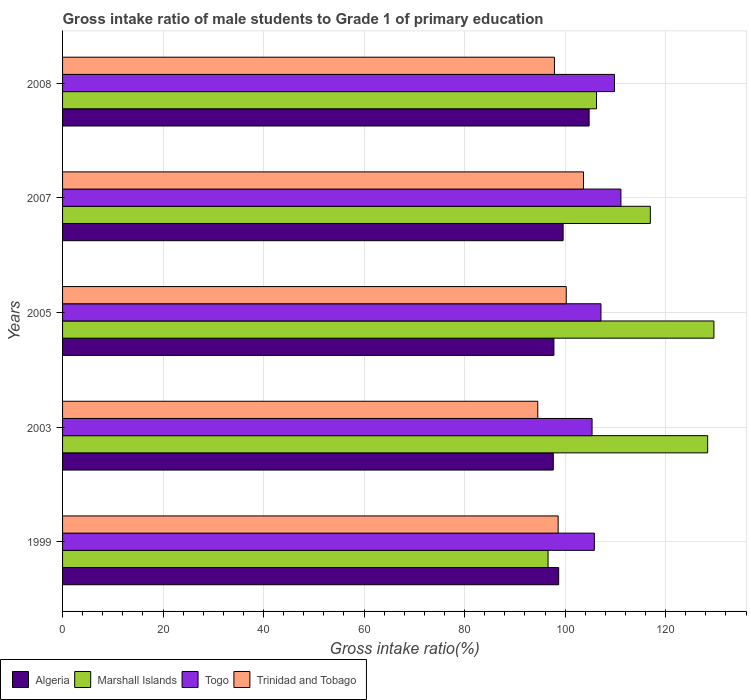How many bars are there on the 5th tick from the bottom?
Provide a short and direct response. 4. What is the label of the 1st group of bars from the top?
Your response must be concise. 2008. In how many cases, is the number of bars for a given year not equal to the number of legend labels?
Your answer should be compact. 0. What is the gross intake ratio in Trinidad and Tobago in 1999?
Ensure brevity in your answer.  98.62. Across all years, what is the maximum gross intake ratio in Togo?
Your response must be concise. 111.11. Across all years, what is the minimum gross intake ratio in Trinidad and Tobago?
Make the answer very short. 94.56. In which year was the gross intake ratio in Marshall Islands minimum?
Give a very brief answer. 1999. What is the total gross intake ratio in Togo in the graph?
Offer a terse response. 539.26. What is the difference between the gross intake ratio in Togo in 1999 and that in 2007?
Provide a short and direct response. -5.28. What is the difference between the gross intake ratio in Algeria in 2005 and the gross intake ratio in Marshall Islands in 1999?
Keep it short and to the point. 1.17. What is the average gross intake ratio in Trinidad and Tobago per year?
Ensure brevity in your answer.  98.99. In the year 2003, what is the difference between the gross intake ratio in Algeria and gross intake ratio in Trinidad and Tobago?
Provide a short and direct response. 3.08. In how many years, is the gross intake ratio in Togo greater than 32 %?
Ensure brevity in your answer.  5. What is the ratio of the gross intake ratio in Marshall Islands in 2003 to that in 2007?
Keep it short and to the point. 1.1. What is the difference between the highest and the second highest gross intake ratio in Algeria?
Provide a short and direct response. 5.18. What is the difference between the highest and the lowest gross intake ratio in Togo?
Provide a short and direct response. 5.74. In how many years, is the gross intake ratio in Marshall Islands greater than the average gross intake ratio in Marshall Islands taken over all years?
Your answer should be compact. 3. Is the sum of the gross intake ratio in Algeria in 2003 and 2007 greater than the maximum gross intake ratio in Togo across all years?
Your answer should be very brief. Yes. Is it the case that in every year, the sum of the gross intake ratio in Trinidad and Tobago and gross intake ratio in Algeria is greater than the sum of gross intake ratio in Marshall Islands and gross intake ratio in Togo?
Keep it short and to the point. No. What does the 2nd bar from the top in 2007 represents?
Your answer should be compact. Togo. What does the 1st bar from the bottom in 2008 represents?
Ensure brevity in your answer.  Algeria. Is it the case that in every year, the sum of the gross intake ratio in Algeria and gross intake ratio in Marshall Islands is greater than the gross intake ratio in Togo?
Offer a very short reply. Yes. Are all the bars in the graph horizontal?
Ensure brevity in your answer.  Yes. What is the difference between two consecutive major ticks on the X-axis?
Offer a very short reply. 20. Does the graph contain grids?
Provide a short and direct response. Yes. How many legend labels are there?
Offer a very short reply. 4. What is the title of the graph?
Offer a terse response. Gross intake ratio of male students to Grade 1 of primary education. Does "Arab World" appear as one of the legend labels in the graph?
Provide a short and direct response. No. What is the label or title of the X-axis?
Give a very brief answer. Gross intake ratio(%). What is the Gross intake ratio(%) in Algeria in 1999?
Provide a succinct answer. 98.72. What is the Gross intake ratio(%) in Marshall Islands in 1999?
Offer a terse response. 96.61. What is the Gross intake ratio(%) of Togo in 1999?
Offer a terse response. 105.82. What is the Gross intake ratio(%) in Trinidad and Tobago in 1999?
Your response must be concise. 98.62. What is the Gross intake ratio(%) of Algeria in 2003?
Your response must be concise. 97.65. What is the Gross intake ratio(%) of Marshall Islands in 2003?
Your answer should be compact. 128.37. What is the Gross intake ratio(%) in Togo in 2003?
Your response must be concise. 105.37. What is the Gross intake ratio(%) in Trinidad and Tobago in 2003?
Provide a succinct answer. 94.56. What is the Gross intake ratio(%) in Algeria in 2005?
Make the answer very short. 97.77. What is the Gross intake ratio(%) of Marshall Islands in 2005?
Your answer should be very brief. 129.61. What is the Gross intake ratio(%) in Togo in 2005?
Your answer should be compact. 107.14. What is the Gross intake ratio(%) of Trinidad and Tobago in 2005?
Give a very brief answer. 100.23. What is the Gross intake ratio(%) in Algeria in 2007?
Ensure brevity in your answer.  99.61. What is the Gross intake ratio(%) in Marshall Islands in 2007?
Make the answer very short. 116.96. What is the Gross intake ratio(%) in Togo in 2007?
Provide a succinct answer. 111.11. What is the Gross intake ratio(%) of Trinidad and Tobago in 2007?
Your answer should be compact. 103.66. What is the Gross intake ratio(%) in Algeria in 2008?
Provide a succinct answer. 104.78. What is the Gross intake ratio(%) in Marshall Islands in 2008?
Offer a very short reply. 106.25. What is the Gross intake ratio(%) of Togo in 2008?
Make the answer very short. 109.83. What is the Gross intake ratio(%) of Trinidad and Tobago in 2008?
Keep it short and to the point. 97.88. Across all years, what is the maximum Gross intake ratio(%) in Algeria?
Keep it short and to the point. 104.78. Across all years, what is the maximum Gross intake ratio(%) of Marshall Islands?
Provide a short and direct response. 129.61. Across all years, what is the maximum Gross intake ratio(%) of Togo?
Offer a very short reply. 111.11. Across all years, what is the maximum Gross intake ratio(%) in Trinidad and Tobago?
Your answer should be very brief. 103.66. Across all years, what is the minimum Gross intake ratio(%) of Algeria?
Give a very brief answer. 97.65. Across all years, what is the minimum Gross intake ratio(%) of Marshall Islands?
Ensure brevity in your answer.  96.61. Across all years, what is the minimum Gross intake ratio(%) in Togo?
Your response must be concise. 105.37. Across all years, what is the minimum Gross intake ratio(%) in Trinidad and Tobago?
Ensure brevity in your answer.  94.56. What is the total Gross intake ratio(%) of Algeria in the graph?
Your answer should be compact. 498.53. What is the total Gross intake ratio(%) in Marshall Islands in the graph?
Offer a very short reply. 577.8. What is the total Gross intake ratio(%) in Togo in the graph?
Keep it short and to the point. 539.26. What is the total Gross intake ratio(%) of Trinidad and Tobago in the graph?
Keep it short and to the point. 494.95. What is the difference between the Gross intake ratio(%) of Algeria in 1999 and that in 2003?
Provide a short and direct response. 1.08. What is the difference between the Gross intake ratio(%) in Marshall Islands in 1999 and that in 2003?
Keep it short and to the point. -31.76. What is the difference between the Gross intake ratio(%) of Togo in 1999 and that in 2003?
Provide a succinct answer. 0.46. What is the difference between the Gross intake ratio(%) of Trinidad and Tobago in 1999 and that in 2003?
Keep it short and to the point. 4.06. What is the difference between the Gross intake ratio(%) of Algeria in 1999 and that in 2005?
Provide a short and direct response. 0.95. What is the difference between the Gross intake ratio(%) in Marshall Islands in 1999 and that in 2005?
Your answer should be very brief. -33.01. What is the difference between the Gross intake ratio(%) of Togo in 1999 and that in 2005?
Give a very brief answer. -1.31. What is the difference between the Gross intake ratio(%) of Trinidad and Tobago in 1999 and that in 2005?
Offer a very short reply. -1.61. What is the difference between the Gross intake ratio(%) of Algeria in 1999 and that in 2007?
Provide a short and direct response. -0.88. What is the difference between the Gross intake ratio(%) in Marshall Islands in 1999 and that in 2007?
Ensure brevity in your answer.  -20.35. What is the difference between the Gross intake ratio(%) of Togo in 1999 and that in 2007?
Your response must be concise. -5.28. What is the difference between the Gross intake ratio(%) in Trinidad and Tobago in 1999 and that in 2007?
Your answer should be very brief. -5.04. What is the difference between the Gross intake ratio(%) of Algeria in 1999 and that in 2008?
Give a very brief answer. -6.06. What is the difference between the Gross intake ratio(%) of Marshall Islands in 1999 and that in 2008?
Your answer should be compact. -9.64. What is the difference between the Gross intake ratio(%) of Togo in 1999 and that in 2008?
Provide a succinct answer. -4.01. What is the difference between the Gross intake ratio(%) in Trinidad and Tobago in 1999 and that in 2008?
Your answer should be very brief. 0.74. What is the difference between the Gross intake ratio(%) of Algeria in 2003 and that in 2005?
Your answer should be compact. -0.13. What is the difference between the Gross intake ratio(%) in Marshall Islands in 2003 and that in 2005?
Offer a very short reply. -1.25. What is the difference between the Gross intake ratio(%) in Togo in 2003 and that in 2005?
Offer a terse response. -1.77. What is the difference between the Gross intake ratio(%) in Trinidad and Tobago in 2003 and that in 2005?
Offer a very short reply. -5.67. What is the difference between the Gross intake ratio(%) in Algeria in 2003 and that in 2007?
Ensure brevity in your answer.  -1.96. What is the difference between the Gross intake ratio(%) of Marshall Islands in 2003 and that in 2007?
Give a very brief answer. 11.4. What is the difference between the Gross intake ratio(%) of Togo in 2003 and that in 2007?
Offer a terse response. -5.74. What is the difference between the Gross intake ratio(%) in Trinidad and Tobago in 2003 and that in 2007?
Your response must be concise. -9.1. What is the difference between the Gross intake ratio(%) in Algeria in 2003 and that in 2008?
Your response must be concise. -7.14. What is the difference between the Gross intake ratio(%) of Marshall Islands in 2003 and that in 2008?
Your answer should be compact. 22.12. What is the difference between the Gross intake ratio(%) in Togo in 2003 and that in 2008?
Your response must be concise. -4.46. What is the difference between the Gross intake ratio(%) of Trinidad and Tobago in 2003 and that in 2008?
Keep it short and to the point. -3.32. What is the difference between the Gross intake ratio(%) in Algeria in 2005 and that in 2007?
Keep it short and to the point. -1.83. What is the difference between the Gross intake ratio(%) of Marshall Islands in 2005 and that in 2007?
Your answer should be very brief. 12.65. What is the difference between the Gross intake ratio(%) of Togo in 2005 and that in 2007?
Keep it short and to the point. -3.97. What is the difference between the Gross intake ratio(%) in Trinidad and Tobago in 2005 and that in 2007?
Offer a very short reply. -3.43. What is the difference between the Gross intake ratio(%) of Algeria in 2005 and that in 2008?
Offer a terse response. -7.01. What is the difference between the Gross intake ratio(%) in Marshall Islands in 2005 and that in 2008?
Ensure brevity in your answer.  23.36. What is the difference between the Gross intake ratio(%) in Togo in 2005 and that in 2008?
Your answer should be very brief. -2.69. What is the difference between the Gross intake ratio(%) of Trinidad and Tobago in 2005 and that in 2008?
Ensure brevity in your answer.  2.35. What is the difference between the Gross intake ratio(%) of Algeria in 2007 and that in 2008?
Give a very brief answer. -5.18. What is the difference between the Gross intake ratio(%) of Marshall Islands in 2007 and that in 2008?
Your answer should be compact. 10.71. What is the difference between the Gross intake ratio(%) of Togo in 2007 and that in 2008?
Give a very brief answer. 1.28. What is the difference between the Gross intake ratio(%) of Trinidad and Tobago in 2007 and that in 2008?
Make the answer very short. 5.78. What is the difference between the Gross intake ratio(%) of Algeria in 1999 and the Gross intake ratio(%) of Marshall Islands in 2003?
Offer a very short reply. -29.64. What is the difference between the Gross intake ratio(%) in Algeria in 1999 and the Gross intake ratio(%) in Togo in 2003?
Offer a terse response. -6.64. What is the difference between the Gross intake ratio(%) in Algeria in 1999 and the Gross intake ratio(%) in Trinidad and Tobago in 2003?
Your answer should be compact. 4.16. What is the difference between the Gross intake ratio(%) in Marshall Islands in 1999 and the Gross intake ratio(%) in Togo in 2003?
Your answer should be very brief. -8.76. What is the difference between the Gross intake ratio(%) of Marshall Islands in 1999 and the Gross intake ratio(%) of Trinidad and Tobago in 2003?
Give a very brief answer. 2.05. What is the difference between the Gross intake ratio(%) in Togo in 1999 and the Gross intake ratio(%) in Trinidad and Tobago in 2003?
Ensure brevity in your answer.  11.26. What is the difference between the Gross intake ratio(%) in Algeria in 1999 and the Gross intake ratio(%) in Marshall Islands in 2005?
Your response must be concise. -30.89. What is the difference between the Gross intake ratio(%) of Algeria in 1999 and the Gross intake ratio(%) of Togo in 2005?
Ensure brevity in your answer.  -8.41. What is the difference between the Gross intake ratio(%) in Algeria in 1999 and the Gross intake ratio(%) in Trinidad and Tobago in 2005?
Offer a very short reply. -1.5. What is the difference between the Gross intake ratio(%) in Marshall Islands in 1999 and the Gross intake ratio(%) in Togo in 2005?
Offer a very short reply. -10.53. What is the difference between the Gross intake ratio(%) in Marshall Islands in 1999 and the Gross intake ratio(%) in Trinidad and Tobago in 2005?
Keep it short and to the point. -3.62. What is the difference between the Gross intake ratio(%) of Togo in 1999 and the Gross intake ratio(%) of Trinidad and Tobago in 2005?
Keep it short and to the point. 5.6. What is the difference between the Gross intake ratio(%) in Algeria in 1999 and the Gross intake ratio(%) in Marshall Islands in 2007?
Offer a terse response. -18.24. What is the difference between the Gross intake ratio(%) in Algeria in 1999 and the Gross intake ratio(%) in Togo in 2007?
Ensure brevity in your answer.  -12.38. What is the difference between the Gross intake ratio(%) in Algeria in 1999 and the Gross intake ratio(%) in Trinidad and Tobago in 2007?
Ensure brevity in your answer.  -4.94. What is the difference between the Gross intake ratio(%) of Marshall Islands in 1999 and the Gross intake ratio(%) of Togo in 2007?
Offer a terse response. -14.5. What is the difference between the Gross intake ratio(%) of Marshall Islands in 1999 and the Gross intake ratio(%) of Trinidad and Tobago in 2007?
Give a very brief answer. -7.05. What is the difference between the Gross intake ratio(%) in Togo in 1999 and the Gross intake ratio(%) in Trinidad and Tobago in 2007?
Provide a short and direct response. 2.16. What is the difference between the Gross intake ratio(%) of Algeria in 1999 and the Gross intake ratio(%) of Marshall Islands in 2008?
Give a very brief answer. -7.53. What is the difference between the Gross intake ratio(%) of Algeria in 1999 and the Gross intake ratio(%) of Togo in 2008?
Your answer should be compact. -11.1. What is the difference between the Gross intake ratio(%) in Algeria in 1999 and the Gross intake ratio(%) in Trinidad and Tobago in 2008?
Your answer should be very brief. 0.85. What is the difference between the Gross intake ratio(%) of Marshall Islands in 1999 and the Gross intake ratio(%) of Togo in 2008?
Make the answer very short. -13.22. What is the difference between the Gross intake ratio(%) of Marshall Islands in 1999 and the Gross intake ratio(%) of Trinidad and Tobago in 2008?
Your answer should be compact. -1.27. What is the difference between the Gross intake ratio(%) in Togo in 1999 and the Gross intake ratio(%) in Trinidad and Tobago in 2008?
Ensure brevity in your answer.  7.94. What is the difference between the Gross intake ratio(%) of Algeria in 2003 and the Gross intake ratio(%) of Marshall Islands in 2005?
Your answer should be compact. -31.97. What is the difference between the Gross intake ratio(%) of Algeria in 2003 and the Gross intake ratio(%) of Togo in 2005?
Offer a very short reply. -9.49. What is the difference between the Gross intake ratio(%) in Algeria in 2003 and the Gross intake ratio(%) in Trinidad and Tobago in 2005?
Ensure brevity in your answer.  -2.58. What is the difference between the Gross intake ratio(%) in Marshall Islands in 2003 and the Gross intake ratio(%) in Togo in 2005?
Provide a short and direct response. 21.23. What is the difference between the Gross intake ratio(%) of Marshall Islands in 2003 and the Gross intake ratio(%) of Trinidad and Tobago in 2005?
Your answer should be compact. 28.14. What is the difference between the Gross intake ratio(%) in Togo in 2003 and the Gross intake ratio(%) in Trinidad and Tobago in 2005?
Your answer should be very brief. 5.14. What is the difference between the Gross intake ratio(%) in Algeria in 2003 and the Gross intake ratio(%) in Marshall Islands in 2007?
Your answer should be compact. -19.31. What is the difference between the Gross intake ratio(%) in Algeria in 2003 and the Gross intake ratio(%) in Togo in 2007?
Provide a short and direct response. -13.46. What is the difference between the Gross intake ratio(%) of Algeria in 2003 and the Gross intake ratio(%) of Trinidad and Tobago in 2007?
Give a very brief answer. -6.02. What is the difference between the Gross intake ratio(%) of Marshall Islands in 2003 and the Gross intake ratio(%) of Togo in 2007?
Offer a terse response. 17.26. What is the difference between the Gross intake ratio(%) in Marshall Islands in 2003 and the Gross intake ratio(%) in Trinidad and Tobago in 2007?
Make the answer very short. 24.7. What is the difference between the Gross intake ratio(%) in Togo in 2003 and the Gross intake ratio(%) in Trinidad and Tobago in 2007?
Your response must be concise. 1.71. What is the difference between the Gross intake ratio(%) of Algeria in 2003 and the Gross intake ratio(%) of Marshall Islands in 2008?
Your response must be concise. -8.6. What is the difference between the Gross intake ratio(%) in Algeria in 2003 and the Gross intake ratio(%) in Togo in 2008?
Your answer should be compact. -12.18. What is the difference between the Gross intake ratio(%) of Algeria in 2003 and the Gross intake ratio(%) of Trinidad and Tobago in 2008?
Offer a very short reply. -0.23. What is the difference between the Gross intake ratio(%) of Marshall Islands in 2003 and the Gross intake ratio(%) of Togo in 2008?
Provide a succinct answer. 18.54. What is the difference between the Gross intake ratio(%) in Marshall Islands in 2003 and the Gross intake ratio(%) in Trinidad and Tobago in 2008?
Your answer should be compact. 30.49. What is the difference between the Gross intake ratio(%) of Togo in 2003 and the Gross intake ratio(%) of Trinidad and Tobago in 2008?
Keep it short and to the point. 7.49. What is the difference between the Gross intake ratio(%) of Algeria in 2005 and the Gross intake ratio(%) of Marshall Islands in 2007?
Make the answer very short. -19.19. What is the difference between the Gross intake ratio(%) of Algeria in 2005 and the Gross intake ratio(%) of Togo in 2007?
Offer a very short reply. -13.33. What is the difference between the Gross intake ratio(%) of Algeria in 2005 and the Gross intake ratio(%) of Trinidad and Tobago in 2007?
Your response must be concise. -5.89. What is the difference between the Gross intake ratio(%) in Marshall Islands in 2005 and the Gross intake ratio(%) in Togo in 2007?
Your answer should be very brief. 18.51. What is the difference between the Gross intake ratio(%) in Marshall Islands in 2005 and the Gross intake ratio(%) in Trinidad and Tobago in 2007?
Keep it short and to the point. 25.95. What is the difference between the Gross intake ratio(%) in Togo in 2005 and the Gross intake ratio(%) in Trinidad and Tobago in 2007?
Your answer should be compact. 3.47. What is the difference between the Gross intake ratio(%) in Algeria in 2005 and the Gross intake ratio(%) in Marshall Islands in 2008?
Keep it short and to the point. -8.48. What is the difference between the Gross intake ratio(%) in Algeria in 2005 and the Gross intake ratio(%) in Togo in 2008?
Your response must be concise. -12.05. What is the difference between the Gross intake ratio(%) of Algeria in 2005 and the Gross intake ratio(%) of Trinidad and Tobago in 2008?
Ensure brevity in your answer.  -0.1. What is the difference between the Gross intake ratio(%) in Marshall Islands in 2005 and the Gross intake ratio(%) in Togo in 2008?
Give a very brief answer. 19.78. What is the difference between the Gross intake ratio(%) of Marshall Islands in 2005 and the Gross intake ratio(%) of Trinidad and Tobago in 2008?
Ensure brevity in your answer.  31.73. What is the difference between the Gross intake ratio(%) of Togo in 2005 and the Gross intake ratio(%) of Trinidad and Tobago in 2008?
Provide a succinct answer. 9.26. What is the difference between the Gross intake ratio(%) in Algeria in 2007 and the Gross intake ratio(%) in Marshall Islands in 2008?
Keep it short and to the point. -6.64. What is the difference between the Gross intake ratio(%) of Algeria in 2007 and the Gross intake ratio(%) of Togo in 2008?
Your response must be concise. -10.22. What is the difference between the Gross intake ratio(%) in Algeria in 2007 and the Gross intake ratio(%) in Trinidad and Tobago in 2008?
Ensure brevity in your answer.  1.73. What is the difference between the Gross intake ratio(%) of Marshall Islands in 2007 and the Gross intake ratio(%) of Togo in 2008?
Keep it short and to the point. 7.13. What is the difference between the Gross intake ratio(%) of Marshall Islands in 2007 and the Gross intake ratio(%) of Trinidad and Tobago in 2008?
Ensure brevity in your answer.  19.08. What is the difference between the Gross intake ratio(%) in Togo in 2007 and the Gross intake ratio(%) in Trinidad and Tobago in 2008?
Keep it short and to the point. 13.23. What is the average Gross intake ratio(%) of Algeria per year?
Your answer should be compact. 99.71. What is the average Gross intake ratio(%) of Marshall Islands per year?
Give a very brief answer. 115.56. What is the average Gross intake ratio(%) in Togo per year?
Keep it short and to the point. 107.85. What is the average Gross intake ratio(%) of Trinidad and Tobago per year?
Your answer should be very brief. 98.99. In the year 1999, what is the difference between the Gross intake ratio(%) in Algeria and Gross intake ratio(%) in Marshall Islands?
Your response must be concise. 2.12. In the year 1999, what is the difference between the Gross intake ratio(%) in Algeria and Gross intake ratio(%) in Togo?
Offer a very short reply. -7.1. In the year 1999, what is the difference between the Gross intake ratio(%) in Algeria and Gross intake ratio(%) in Trinidad and Tobago?
Keep it short and to the point. 0.11. In the year 1999, what is the difference between the Gross intake ratio(%) of Marshall Islands and Gross intake ratio(%) of Togo?
Your answer should be compact. -9.22. In the year 1999, what is the difference between the Gross intake ratio(%) of Marshall Islands and Gross intake ratio(%) of Trinidad and Tobago?
Keep it short and to the point. -2.01. In the year 1999, what is the difference between the Gross intake ratio(%) in Togo and Gross intake ratio(%) in Trinidad and Tobago?
Provide a succinct answer. 7.2. In the year 2003, what is the difference between the Gross intake ratio(%) of Algeria and Gross intake ratio(%) of Marshall Islands?
Keep it short and to the point. -30.72. In the year 2003, what is the difference between the Gross intake ratio(%) of Algeria and Gross intake ratio(%) of Togo?
Provide a succinct answer. -7.72. In the year 2003, what is the difference between the Gross intake ratio(%) of Algeria and Gross intake ratio(%) of Trinidad and Tobago?
Ensure brevity in your answer.  3.08. In the year 2003, what is the difference between the Gross intake ratio(%) in Marshall Islands and Gross intake ratio(%) in Togo?
Provide a short and direct response. 23. In the year 2003, what is the difference between the Gross intake ratio(%) in Marshall Islands and Gross intake ratio(%) in Trinidad and Tobago?
Provide a succinct answer. 33.8. In the year 2003, what is the difference between the Gross intake ratio(%) of Togo and Gross intake ratio(%) of Trinidad and Tobago?
Keep it short and to the point. 10.8. In the year 2005, what is the difference between the Gross intake ratio(%) of Algeria and Gross intake ratio(%) of Marshall Islands?
Your response must be concise. -31.84. In the year 2005, what is the difference between the Gross intake ratio(%) in Algeria and Gross intake ratio(%) in Togo?
Provide a short and direct response. -9.36. In the year 2005, what is the difference between the Gross intake ratio(%) of Algeria and Gross intake ratio(%) of Trinidad and Tobago?
Offer a terse response. -2.45. In the year 2005, what is the difference between the Gross intake ratio(%) of Marshall Islands and Gross intake ratio(%) of Togo?
Offer a very short reply. 22.48. In the year 2005, what is the difference between the Gross intake ratio(%) of Marshall Islands and Gross intake ratio(%) of Trinidad and Tobago?
Your answer should be compact. 29.39. In the year 2005, what is the difference between the Gross intake ratio(%) in Togo and Gross intake ratio(%) in Trinidad and Tobago?
Provide a succinct answer. 6.91. In the year 2007, what is the difference between the Gross intake ratio(%) in Algeria and Gross intake ratio(%) in Marshall Islands?
Offer a very short reply. -17.36. In the year 2007, what is the difference between the Gross intake ratio(%) in Algeria and Gross intake ratio(%) in Togo?
Your response must be concise. -11.5. In the year 2007, what is the difference between the Gross intake ratio(%) in Algeria and Gross intake ratio(%) in Trinidad and Tobago?
Keep it short and to the point. -4.06. In the year 2007, what is the difference between the Gross intake ratio(%) in Marshall Islands and Gross intake ratio(%) in Togo?
Your answer should be very brief. 5.85. In the year 2007, what is the difference between the Gross intake ratio(%) of Marshall Islands and Gross intake ratio(%) of Trinidad and Tobago?
Ensure brevity in your answer.  13.3. In the year 2007, what is the difference between the Gross intake ratio(%) in Togo and Gross intake ratio(%) in Trinidad and Tobago?
Your answer should be very brief. 7.45. In the year 2008, what is the difference between the Gross intake ratio(%) of Algeria and Gross intake ratio(%) of Marshall Islands?
Offer a very short reply. -1.47. In the year 2008, what is the difference between the Gross intake ratio(%) in Algeria and Gross intake ratio(%) in Togo?
Keep it short and to the point. -5.05. In the year 2008, what is the difference between the Gross intake ratio(%) of Algeria and Gross intake ratio(%) of Trinidad and Tobago?
Offer a terse response. 6.9. In the year 2008, what is the difference between the Gross intake ratio(%) in Marshall Islands and Gross intake ratio(%) in Togo?
Your response must be concise. -3.58. In the year 2008, what is the difference between the Gross intake ratio(%) in Marshall Islands and Gross intake ratio(%) in Trinidad and Tobago?
Keep it short and to the point. 8.37. In the year 2008, what is the difference between the Gross intake ratio(%) of Togo and Gross intake ratio(%) of Trinidad and Tobago?
Offer a very short reply. 11.95. What is the ratio of the Gross intake ratio(%) of Marshall Islands in 1999 to that in 2003?
Keep it short and to the point. 0.75. What is the ratio of the Gross intake ratio(%) in Togo in 1999 to that in 2003?
Keep it short and to the point. 1. What is the ratio of the Gross intake ratio(%) in Trinidad and Tobago in 1999 to that in 2003?
Give a very brief answer. 1.04. What is the ratio of the Gross intake ratio(%) in Algeria in 1999 to that in 2005?
Provide a short and direct response. 1.01. What is the ratio of the Gross intake ratio(%) in Marshall Islands in 1999 to that in 2005?
Make the answer very short. 0.75. What is the ratio of the Gross intake ratio(%) in Togo in 1999 to that in 2005?
Your answer should be compact. 0.99. What is the ratio of the Gross intake ratio(%) in Marshall Islands in 1999 to that in 2007?
Your answer should be compact. 0.83. What is the ratio of the Gross intake ratio(%) of Trinidad and Tobago in 1999 to that in 2007?
Ensure brevity in your answer.  0.95. What is the ratio of the Gross intake ratio(%) of Algeria in 1999 to that in 2008?
Your answer should be compact. 0.94. What is the ratio of the Gross intake ratio(%) of Marshall Islands in 1999 to that in 2008?
Offer a very short reply. 0.91. What is the ratio of the Gross intake ratio(%) in Togo in 1999 to that in 2008?
Keep it short and to the point. 0.96. What is the ratio of the Gross intake ratio(%) in Trinidad and Tobago in 1999 to that in 2008?
Keep it short and to the point. 1.01. What is the ratio of the Gross intake ratio(%) of Togo in 2003 to that in 2005?
Ensure brevity in your answer.  0.98. What is the ratio of the Gross intake ratio(%) in Trinidad and Tobago in 2003 to that in 2005?
Give a very brief answer. 0.94. What is the ratio of the Gross intake ratio(%) of Algeria in 2003 to that in 2007?
Give a very brief answer. 0.98. What is the ratio of the Gross intake ratio(%) of Marshall Islands in 2003 to that in 2007?
Make the answer very short. 1.1. What is the ratio of the Gross intake ratio(%) in Togo in 2003 to that in 2007?
Provide a short and direct response. 0.95. What is the ratio of the Gross intake ratio(%) of Trinidad and Tobago in 2003 to that in 2007?
Your answer should be very brief. 0.91. What is the ratio of the Gross intake ratio(%) in Algeria in 2003 to that in 2008?
Give a very brief answer. 0.93. What is the ratio of the Gross intake ratio(%) in Marshall Islands in 2003 to that in 2008?
Your answer should be very brief. 1.21. What is the ratio of the Gross intake ratio(%) in Togo in 2003 to that in 2008?
Make the answer very short. 0.96. What is the ratio of the Gross intake ratio(%) of Trinidad and Tobago in 2003 to that in 2008?
Offer a very short reply. 0.97. What is the ratio of the Gross intake ratio(%) in Algeria in 2005 to that in 2007?
Offer a terse response. 0.98. What is the ratio of the Gross intake ratio(%) of Marshall Islands in 2005 to that in 2007?
Provide a succinct answer. 1.11. What is the ratio of the Gross intake ratio(%) of Togo in 2005 to that in 2007?
Make the answer very short. 0.96. What is the ratio of the Gross intake ratio(%) in Trinidad and Tobago in 2005 to that in 2007?
Provide a short and direct response. 0.97. What is the ratio of the Gross intake ratio(%) of Algeria in 2005 to that in 2008?
Give a very brief answer. 0.93. What is the ratio of the Gross intake ratio(%) of Marshall Islands in 2005 to that in 2008?
Offer a very short reply. 1.22. What is the ratio of the Gross intake ratio(%) in Togo in 2005 to that in 2008?
Offer a terse response. 0.98. What is the ratio of the Gross intake ratio(%) of Trinidad and Tobago in 2005 to that in 2008?
Offer a very short reply. 1.02. What is the ratio of the Gross intake ratio(%) of Algeria in 2007 to that in 2008?
Give a very brief answer. 0.95. What is the ratio of the Gross intake ratio(%) in Marshall Islands in 2007 to that in 2008?
Give a very brief answer. 1.1. What is the ratio of the Gross intake ratio(%) in Togo in 2007 to that in 2008?
Make the answer very short. 1.01. What is the ratio of the Gross intake ratio(%) of Trinidad and Tobago in 2007 to that in 2008?
Provide a succinct answer. 1.06. What is the difference between the highest and the second highest Gross intake ratio(%) in Algeria?
Keep it short and to the point. 5.18. What is the difference between the highest and the second highest Gross intake ratio(%) of Marshall Islands?
Provide a short and direct response. 1.25. What is the difference between the highest and the second highest Gross intake ratio(%) in Togo?
Keep it short and to the point. 1.28. What is the difference between the highest and the second highest Gross intake ratio(%) in Trinidad and Tobago?
Keep it short and to the point. 3.43. What is the difference between the highest and the lowest Gross intake ratio(%) of Algeria?
Your answer should be compact. 7.14. What is the difference between the highest and the lowest Gross intake ratio(%) in Marshall Islands?
Provide a short and direct response. 33.01. What is the difference between the highest and the lowest Gross intake ratio(%) of Togo?
Offer a very short reply. 5.74. What is the difference between the highest and the lowest Gross intake ratio(%) of Trinidad and Tobago?
Your response must be concise. 9.1. 